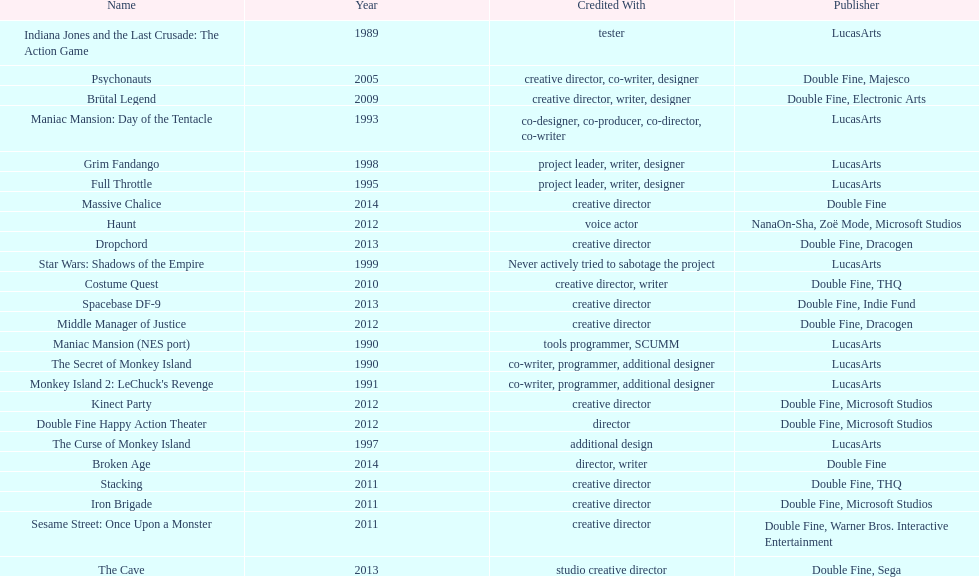Which game is credited with a creative director and warner bros. interactive entertainment as their creative director? Sesame Street: Once Upon a Monster. 